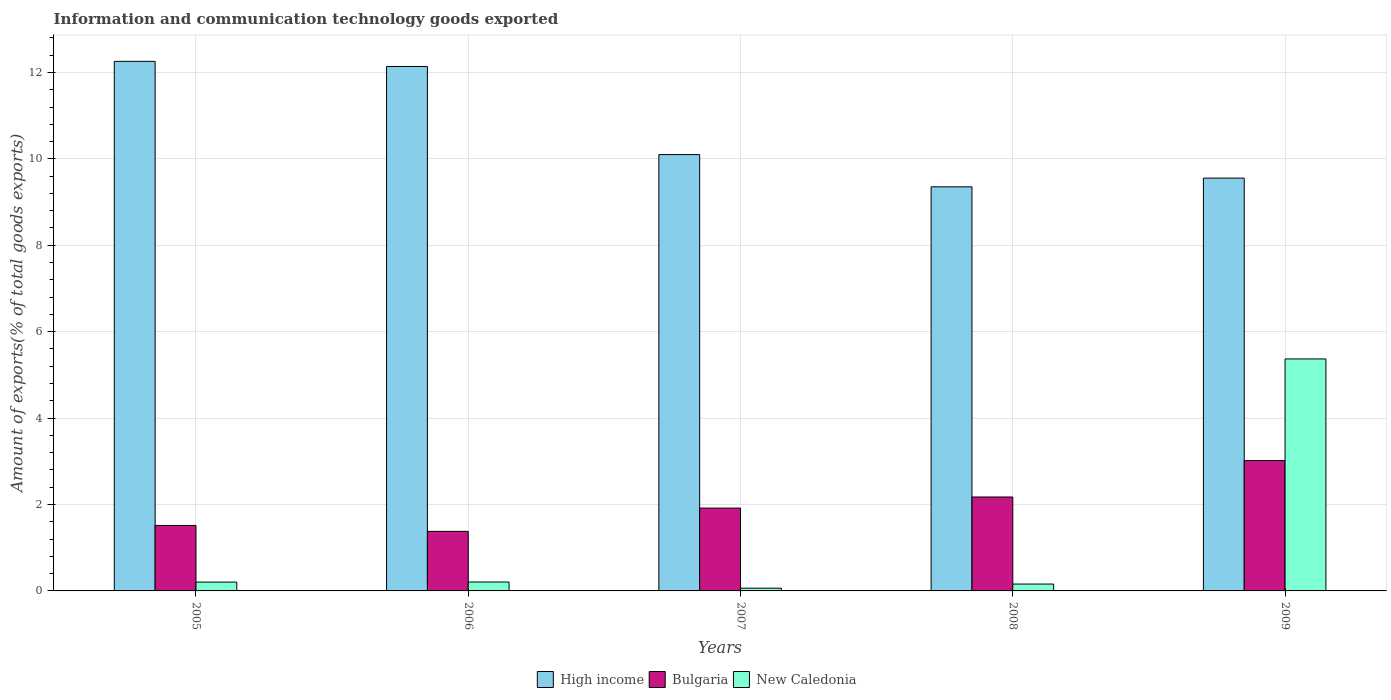How many different coloured bars are there?
Ensure brevity in your answer.  3. How many groups of bars are there?
Ensure brevity in your answer.  5. Are the number of bars on each tick of the X-axis equal?
Offer a very short reply. Yes. What is the label of the 4th group of bars from the left?
Your response must be concise. 2008. What is the amount of goods exported in Bulgaria in 2005?
Provide a succinct answer. 1.52. Across all years, what is the maximum amount of goods exported in Bulgaria?
Your answer should be very brief. 3.02. Across all years, what is the minimum amount of goods exported in New Caledonia?
Your answer should be very brief. 0.06. In which year was the amount of goods exported in High income maximum?
Offer a very short reply. 2005. In which year was the amount of goods exported in Bulgaria minimum?
Ensure brevity in your answer.  2006. What is the total amount of goods exported in New Caledonia in the graph?
Give a very brief answer. 6. What is the difference between the amount of goods exported in Bulgaria in 2006 and that in 2009?
Give a very brief answer. -1.64. What is the difference between the amount of goods exported in Bulgaria in 2005 and the amount of goods exported in New Caledonia in 2006?
Offer a very short reply. 1.31. What is the average amount of goods exported in New Caledonia per year?
Provide a short and direct response. 1.2. In the year 2008, what is the difference between the amount of goods exported in High income and amount of goods exported in New Caledonia?
Offer a terse response. 9.19. In how many years, is the amount of goods exported in New Caledonia greater than 1.2000000000000002 %?
Offer a very short reply. 1. What is the ratio of the amount of goods exported in High income in 2005 to that in 2006?
Offer a terse response. 1.01. Is the amount of goods exported in Bulgaria in 2005 less than that in 2009?
Offer a very short reply. Yes. What is the difference between the highest and the second highest amount of goods exported in High income?
Ensure brevity in your answer.  0.12. What is the difference between the highest and the lowest amount of goods exported in High income?
Provide a succinct answer. 2.9. In how many years, is the amount of goods exported in New Caledonia greater than the average amount of goods exported in New Caledonia taken over all years?
Your response must be concise. 1. Is the sum of the amount of goods exported in New Caledonia in 2008 and 2009 greater than the maximum amount of goods exported in High income across all years?
Give a very brief answer. No. What does the 1st bar from the left in 2007 represents?
Your response must be concise. High income. What does the 3rd bar from the right in 2005 represents?
Offer a very short reply. High income. How many bars are there?
Provide a succinct answer. 15. What is the difference between two consecutive major ticks on the Y-axis?
Ensure brevity in your answer.  2. Does the graph contain any zero values?
Make the answer very short. No. Does the graph contain grids?
Offer a terse response. Yes. What is the title of the graph?
Make the answer very short. Information and communication technology goods exported. Does "Marshall Islands" appear as one of the legend labels in the graph?
Give a very brief answer. No. What is the label or title of the Y-axis?
Ensure brevity in your answer.  Amount of exports(% of total goods exports). What is the Amount of exports(% of total goods exports) of High income in 2005?
Offer a very short reply. 12.26. What is the Amount of exports(% of total goods exports) in Bulgaria in 2005?
Keep it short and to the point. 1.52. What is the Amount of exports(% of total goods exports) in New Caledonia in 2005?
Offer a very short reply. 0.2. What is the Amount of exports(% of total goods exports) of High income in 2006?
Your answer should be compact. 12.14. What is the Amount of exports(% of total goods exports) of Bulgaria in 2006?
Ensure brevity in your answer.  1.38. What is the Amount of exports(% of total goods exports) of New Caledonia in 2006?
Offer a terse response. 0.21. What is the Amount of exports(% of total goods exports) in High income in 2007?
Your answer should be very brief. 10.1. What is the Amount of exports(% of total goods exports) in Bulgaria in 2007?
Provide a succinct answer. 1.92. What is the Amount of exports(% of total goods exports) in New Caledonia in 2007?
Keep it short and to the point. 0.06. What is the Amount of exports(% of total goods exports) in High income in 2008?
Keep it short and to the point. 9.35. What is the Amount of exports(% of total goods exports) in Bulgaria in 2008?
Ensure brevity in your answer.  2.17. What is the Amount of exports(% of total goods exports) of New Caledonia in 2008?
Make the answer very short. 0.16. What is the Amount of exports(% of total goods exports) in High income in 2009?
Ensure brevity in your answer.  9.55. What is the Amount of exports(% of total goods exports) of Bulgaria in 2009?
Offer a very short reply. 3.02. What is the Amount of exports(% of total goods exports) of New Caledonia in 2009?
Your answer should be very brief. 5.37. Across all years, what is the maximum Amount of exports(% of total goods exports) in High income?
Ensure brevity in your answer.  12.26. Across all years, what is the maximum Amount of exports(% of total goods exports) in Bulgaria?
Offer a very short reply. 3.02. Across all years, what is the maximum Amount of exports(% of total goods exports) of New Caledonia?
Make the answer very short. 5.37. Across all years, what is the minimum Amount of exports(% of total goods exports) in High income?
Your answer should be very brief. 9.35. Across all years, what is the minimum Amount of exports(% of total goods exports) of Bulgaria?
Give a very brief answer. 1.38. Across all years, what is the minimum Amount of exports(% of total goods exports) of New Caledonia?
Give a very brief answer. 0.06. What is the total Amount of exports(% of total goods exports) in High income in the graph?
Keep it short and to the point. 53.4. What is the total Amount of exports(% of total goods exports) in Bulgaria in the graph?
Provide a succinct answer. 10. What is the total Amount of exports(% of total goods exports) in New Caledonia in the graph?
Make the answer very short. 6. What is the difference between the Amount of exports(% of total goods exports) of High income in 2005 and that in 2006?
Your answer should be very brief. 0.12. What is the difference between the Amount of exports(% of total goods exports) in Bulgaria in 2005 and that in 2006?
Offer a terse response. 0.14. What is the difference between the Amount of exports(% of total goods exports) in New Caledonia in 2005 and that in 2006?
Offer a very short reply. -0. What is the difference between the Amount of exports(% of total goods exports) in High income in 2005 and that in 2007?
Your answer should be very brief. 2.16. What is the difference between the Amount of exports(% of total goods exports) of Bulgaria in 2005 and that in 2007?
Offer a very short reply. -0.4. What is the difference between the Amount of exports(% of total goods exports) in New Caledonia in 2005 and that in 2007?
Offer a very short reply. 0.14. What is the difference between the Amount of exports(% of total goods exports) of High income in 2005 and that in 2008?
Your answer should be very brief. 2.9. What is the difference between the Amount of exports(% of total goods exports) of Bulgaria in 2005 and that in 2008?
Give a very brief answer. -0.66. What is the difference between the Amount of exports(% of total goods exports) in New Caledonia in 2005 and that in 2008?
Ensure brevity in your answer.  0.05. What is the difference between the Amount of exports(% of total goods exports) of High income in 2005 and that in 2009?
Your answer should be compact. 2.7. What is the difference between the Amount of exports(% of total goods exports) in Bulgaria in 2005 and that in 2009?
Keep it short and to the point. -1.5. What is the difference between the Amount of exports(% of total goods exports) in New Caledonia in 2005 and that in 2009?
Give a very brief answer. -5.17. What is the difference between the Amount of exports(% of total goods exports) in High income in 2006 and that in 2007?
Ensure brevity in your answer.  2.04. What is the difference between the Amount of exports(% of total goods exports) of Bulgaria in 2006 and that in 2007?
Offer a very short reply. -0.54. What is the difference between the Amount of exports(% of total goods exports) of New Caledonia in 2006 and that in 2007?
Provide a short and direct response. 0.14. What is the difference between the Amount of exports(% of total goods exports) of High income in 2006 and that in 2008?
Your answer should be compact. 2.79. What is the difference between the Amount of exports(% of total goods exports) of Bulgaria in 2006 and that in 2008?
Offer a very short reply. -0.8. What is the difference between the Amount of exports(% of total goods exports) of New Caledonia in 2006 and that in 2008?
Make the answer very short. 0.05. What is the difference between the Amount of exports(% of total goods exports) in High income in 2006 and that in 2009?
Keep it short and to the point. 2.58. What is the difference between the Amount of exports(% of total goods exports) of Bulgaria in 2006 and that in 2009?
Your response must be concise. -1.64. What is the difference between the Amount of exports(% of total goods exports) in New Caledonia in 2006 and that in 2009?
Make the answer very short. -5.16. What is the difference between the Amount of exports(% of total goods exports) in High income in 2007 and that in 2008?
Provide a short and direct response. 0.75. What is the difference between the Amount of exports(% of total goods exports) in Bulgaria in 2007 and that in 2008?
Your answer should be very brief. -0.26. What is the difference between the Amount of exports(% of total goods exports) of New Caledonia in 2007 and that in 2008?
Keep it short and to the point. -0.1. What is the difference between the Amount of exports(% of total goods exports) in High income in 2007 and that in 2009?
Your response must be concise. 0.54. What is the difference between the Amount of exports(% of total goods exports) in Bulgaria in 2007 and that in 2009?
Ensure brevity in your answer.  -1.1. What is the difference between the Amount of exports(% of total goods exports) in New Caledonia in 2007 and that in 2009?
Make the answer very short. -5.31. What is the difference between the Amount of exports(% of total goods exports) of High income in 2008 and that in 2009?
Ensure brevity in your answer.  -0.2. What is the difference between the Amount of exports(% of total goods exports) in Bulgaria in 2008 and that in 2009?
Provide a succinct answer. -0.84. What is the difference between the Amount of exports(% of total goods exports) in New Caledonia in 2008 and that in 2009?
Offer a terse response. -5.21. What is the difference between the Amount of exports(% of total goods exports) of High income in 2005 and the Amount of exports(% of total goods exports) of Bulgaria in 2006?
Offer a terse response. 10.88. What is the difference between the Amount of exports(% of total goods exports) in High income in 2005 and the Amount of exports(% of total goods exports) in New Caledonia in 2006?
Offer a very short reply. 12.05. What is the difference between the Amount of exports(% of total goods exports) in Bulgaria in 2005 and the Amount of exports(% of total goods exports) in New Caledonia in 2006?
Your response must be concise. 1.31. What is the difference between the Amount of exports(% of total goods exports) of High income in 2005 and the Amount of exports(% of total goods exports) of Bulgaria in 2007?
Your response must be concise. 10.34. What is the difference between the Amount of exports(% of total goods exports) in High income in 2005 and the Amount of exports(% of total goods exports) in New Caledonia in 2007?
Your answer should be compact. 12.19. What is the difference between the Amount of exports(% of total goods exports) of Bulgaria in 2005 and the Amount of exports(% of total goods exports) of New Caledonia in 2007?
Offer a very short reply. 1.45. What is the difference between the Amount of exports(% of total goods exports) in High income in 2005 and the Amount of exports(% of total goods exports) in Bulgaria in 2008?
Ensure brevity in your answer.  10.08. What is the difference between the Amount of exports(% of total goods exports) in High income in 2005 and the Amount of exports(% of total goods exports) in New Caledonia in 2008?
Your response must be concise. 12.1. What is the difference between the Amount of exports(% of total goods exports) of Bulgaria in 2005 and the Amount of exports(% of total goods exports) of New Caledonia in 2008?
Offer a very short reply. 1.36. What is the difference between the Amount of exports(% of total goods exports) of High income in 2005 and the Amount of exports(% of total goods exports) of Bulgaria in 2009?
Offer a very short reply. 9.24. What is the difference between the Amount of exports(% of total goods exports) in High income in 2005 and the Amount of exports(% of total goods exports) in New Caledonia in 2009?
Your answer should be very brief. 6.89. What is the difference between the Amount of exports(% of total goods exports) of Bulgaria in 2005 and the Amount of exports(% of total goods exports) of New Caledonia in 2009?
Make the answer very short. -3.85. What is the difference between the Amount of exports(% of total goods exports) in High income in 2006 and the Amount of exports(% of total goods exports) in Bulgaria in 2007?
Your answer should be compact. 10.22. What is the difference between the Amount of exports(% of total goods exports) of High income in 2006 and the Amount of exports(% of total goods exports) of New Caledonia in 2007?
Provide a succinct answer. 12.08. What is the difference between the Amount of exports(% of total goods exports) of Bulgaria in 2006 and the Amount of exports(% of total goods exports) of New Caledonia in 2007?
Make the answer very short. 1.32. What is the difference between the Amount of exports(% of total goods exports) in High income in 2006 and the Amount of exports(% of total goods exports) in Bulgaria in 2008?
Provide a succinct answer. 9.96. What is the difference between the Amount of exports(% of total goods exports) in High income in 2006 and the Amount of exports(% of total goods exports) in New Caledonia in 2008?
Offer a terse response. 11.98. What is the difference between the Amount of exports(% of total goods exports) of Bulgaria in 2006 and the Amount of exports(% of total goods exports) of New Caledonia in 2008?
Give a very brief answer. 1.22. What is the difference between the Amount of exports(% of total goods exports) of High income in 2006 and the Amount of exports(% of total goods exports) of Bulgaria in 2009?
Your answer should be very brief. 9.12. What is the difference between the Amount of exports(% of total goods exports) in High income in 2006 and the Amount of exports(% of total goods exports) in New Caledonia in 2009?
Provide a short and direct response. 6.77. What is the difference between the Amount of exports(% of total goods exports) of Bulgaria in 2006 and the Amount of exports(% of total goods exports) of New Caledonia in 2009?
Ensure brevity in your answer.  -3.99. What is the difference between the Amount of exports(% of total goods exports) of High income in 2007 and the Amount of exports(% of total goods exports) of Bulgaria in 2008?
Ensure brevity in your answer.  7.93. What is the difference between the Amount of exports(% of total goods exports) of High income in 2007 and the Amount of exports(% of total goods exports) of New Caledonia in 2008?
Your answer should be compact. 9.94. What is the difference between the Amount of exports(% of total goods exports) of Bulgaria in 2007 and the Amount of exports(% of total goods exports) of New Caledonia in 2008?
Offer a terse response. 1.76. What is the difference between the Amount of exports(% of total goods exports) of High income in 2007 and the Amount of exports(% of total goods exports) of Bulgaria in 2009?
Your answer should be very brief. 7.08. What is the difference between the Amount of exports(% of total goods exports) of High income in 2007 and the Amount of exports(% of total goods exports) of New Caledonia in 2009?
Ensure brevity in your answer.  4.73. What is the difference between the Amount of exports(% of total goods exports) in Bulgaria in 2007 and the Amount of exports(% of total goods exports) in New Caledonia in 2009?
Your answer should be compact. -3.45. What is the difference between the Amount of exports(% of total goods exports) in High income in 2008 and the Amount of exports(% of total goods exports) in Bulgaria in 2009?
Give a very brief answer. 6.34. What is the difference between the Amount of exports(% of total goods exports) in High income in 2008 and the Amount of exports(% of total goods exports) in New Caledonia in 2009?
Keep it short and to the point. 3.98. What is the difference between the Amount of exports(% of total goods exports) in Bulgaria in 2008 and the Amount of exports(% of total goods exports) in New Caledonia in 2009?
Your answer should be compact. -3.2. What is the average Amount of exports(% of total goods exports) in High income per year?
Make the answer very short. 10.68. What is the average Amount of exports(% of total goods exports) in Bulgaria per year?
Offer a very short reply. 2. What is the average Amount of exports(% of total goods exports) of New Caledonia per year?
Offer a very short reply. 1.2. In the year 2005, what is the difference between the Amount of exports(% of total goods exports) in High income and Amount of exports(% of total goods exports) in Bulgaria?
Your answer should be compact. 10.74. In the year 2005, what is the difference between the Amount of exports(% of total goods exports) of High income and Amount of exports(% of total goods exports) of New Caledonia?
Provide a short and direct response. 12.05. In the year 2005, what is the difference between the Amount of exports(% of total goods exports) of Bulgaria and Amount of exports(% of total goods exports) of New Caledonia?
Make the answer very short. 1.31. In the year 2006, what is the difference between the Amount of exports(% of total goods exports) in High income and Amount of exports(% of total goods exports) in Bulgaria?
Keep it short and to the point. 10.76. In the year 2006, what is the difference between the Amount of exports(% of total goods exports) in High income and Amount of exports(% of total goods exports) in New Caledonia?
Give a very brief answer. 11.93. In the year 2006, what is the difference between the Amount of exports(% of total goods exports) of Bulgaria and Amount of exports(% of total goods exports) of New Caledonia?
Your response must be concise. 1.17. In the year 2007, what is the difference between the Amount of exports(% of total goods exports) of High income and Amount of exports(% of total goods exports) of Bulgaria?
Make the answer very short. 8.18. In the year 2007, what is the difference between the Amount of exports(% of total goods exports) in High income and Amount of exports(% of total goods exports) in New Caledonia?
Ensure brevity in your answer.  10.04. In the year 2007, what is the difference between the Amount of exports(% of total goods exports) in Bulgaria and Amount of exports(% of total goods exports) in New Caledonia?
Give a very brief answer. 1.85. In the year 2008, what is the difference between the Amount of exports(% of total goods exports) in High income and Amount of exports(% of total goods exports) in Bulgaria?
Give a very brief answer. 7.18. In the year 2008, what is the difference between the Amount of exports(% of total goods exports) of High income and Amount of exports(% of total goods exports) of New Caledonia?
Your answer should be compact. 9.19. In the year 2008, what is the difference between the Amount of exports(% of total goods exports) of Bulgaria and Amount of exports(% of total goods exports) of New Caledonia?
Provide a succinct answer. 2.02. In the year 2009, what is the difference between the Amount of exports(% of total goods exports) of High income and Amount of exports(% of total goods exports) of Bulgaria?
Offer a very short reply. 6.54. In the year 2009, what is the difference between the Amount of exports(% of total goods exports) in High income and Amount of exports(% of total goods exports) in New Caledonia?
Give a very brief answer. 4.18. In the year 2009, what is the difference between the Amount of exports(% of total goods exports) in Bulgaria and Amount of exports(% of total goods exports) in New Caledonia?
Give a very brief answer. -2.35. What is the ratio of the Amount of exports(% of total goods exports) in High income in 2005 to that in 2006?
Ensure brevity in your answer.  1.01. What is the ratio of the Amount of exports(% of total goods exports) of Bulgaria in 2005 to that in 2006?
Your answer should be very brief. 1.1. What is the ratio of the Amount of exports(% of total goods exports) of New Caledonia in 2005 to that in 2006?
Ensure brevity in your answer.  0.99. What is the ratio of the Amount of exports(% of total goods exports) of High income in 2005 to that in 2007?
Ensure brevity in your answer.  1.21. What is the ratio of the Amount of exports(% of total goods exports) of Bulgaria in 2005 to that in 2007?
Make the answer very short. 0.79. What is the ratio of the Amount of exports(% of total goods exports) in New Caledonia in 2005 to that in 2007?
Provide a short and direct response. 3.23. What is the ratio of the Amount of exports(% of total goods exports) of High income in 2005 to that in 2008?
Make the answer very short. 1.31. What is the ratio of the Amount of exports(% of total goods exports) in Bulgaria in 2005 to that in 2008?
Your response must be concise. 0.7. What is the ratio of the Amount of exports(% of total goods exports) of New Caledonia in 2005 to that in 2008?
Keep it short and to the point. 1.28. What is the ratio of the Amount of exports(% of total goods exports) in High income in 2005 to that in 2009?
Your answer should be compact. 1.28. What is the ratio of the Amount of exports(% of total goods exports) in Bulgaria in 2005 to that in 2009?
Provide a short and direct response. 0.5. What is the ratio of the Amount of exports(% of total goods exports) of New Caledonia in 2005 to that in 2009?
Provide a succinct answer. 0.04. What is the ratio of the Amount of exports(% of total goods exports) in High income in 2006 to that in 2007?
Provide a short and direct response. 1.2. What is the ratio of the Amount of exports(% of total goods exports) of Bulgaria in 2006 to that in 2007?
Give a very brief answer. 0.72. What is the ratio of the Amount of exports(% of total goods exports) in New Caledonia in 2006 to that in 2007?
Your answer should be very brief. 3.25. What is the ratio of the Amount of exports(% of total goods exports) in High income in 2006 to that in 2008?
Keep it short and to the point. 1.3. What is the ratio of the Amount of exports(% of total goods exports) in Bulgaria in 2006 to that in 2008?
Your answer should be compact. 0.63. What is the ratio of the Amount of exports(% of total goods exports) of New Caledonia in 2006 to that in 2008?
Your answer should be very brief. 1.29. What is the ratio of the Amount of exports(% of total goods exports) in High income in 2006 to that in 2009?
Your response must be concise. 1.27. What is the ratio of the Amount of exports(% of total goods exports) of Bulgaria in 2006 to that in 2009?
Provide a succinct answer. 0.46. What is the ratio of the Amount of exports(% of total goods exports) in New Caledonia in 2006 to that in 2009?
Your answer should be very brief. 0.04. What is the ratio of the Amount of exports(% of total goods exports) in High income in 2007 to that in 2008?
Your response must be concise. 1.08. What is the ratio of the Amount of exports(% of total goods exports) in Bulgaria in 2007 to that in 2008?
Make the answer very short. 0.88. What is the ratio of the Amount of exports(% of total goods exports) of New Caledonia in 2007 to that in 2008?
Keep it short and to the point. 0.4. What is the ratio of the Amount of exports(% of total goods exports) of High income in 2007 to that in 2009?
Offer a terse response. 1.06. What is the ratio of the Amount of exports(% of total goods exports) in Bulgaria in 2007 to that in 2009?
Your answer should be compact. 0.64. What is the ratio of the Amount of exports(% of total goods exports) in New Caledonia in 2007 to that in 2009?
Keep it short and to the point. 0.01. What is the ratio of the Amount of exports(% of total goods exports) in High income in 2008 to that in 2009?
Provide a succinct answer. 0.98. What is the ratio of the Amount of exports(% of total goods exports) of Bulgaria in 2008 to that in 2009?
Your answer should be very brief. 0.72. What is the ratio of the Amount of exports(% of total goods exports) of New Caledonia in 2008 to that in 2009?
Your answer should be compact. 0.03. What is the difference between the highest and the second highest Amount of exports(% of total goods exports) of High income?
Your response must be concise. 0.12. What is the difference between the highest and the second highest Amount of exports(% of total goods exports) in Bulgaria?
Keep it short and to the point. 0.84. What is the difference between the highest and the second highest Amount of exports(% of total goods exports) of New Caledonia?
Your answer should be compact. 5.16. What is the difference between the highest and the lowest Amount of exports(% of total goods exports) of High income?
Provide a short and direct response. 2.9. What is the difference between the highest and the lowest Amount of exports(% of total goods exports) of Bulgaria?
Give a very brief answer. 1.64. What is the difference between the highest and the lowest Amount of exports(% of total goods exports) of New Caledonia?
Provide a short and direct response. 5.31. 